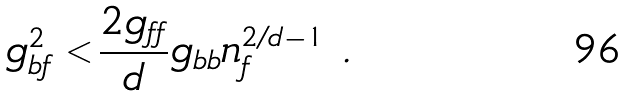<formula> <loc_0><loc_0><loc_500><loc_500>g _ { b f } ^ { 2 } < \frac { 2 g _ { f f } } { d } g _ { b b } n _ { f } ^ { 2 / d - 1 } \ .</formula> 